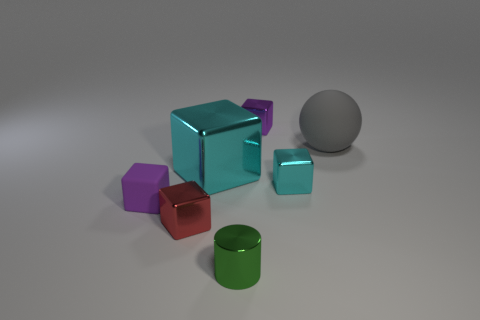What size is the cyan metal thing behind the cyan metallic thing to the right of the small metal cylinder in front of the red object?
Offer a very short reply. Large. What is the color of the thing that is on the left side of the tiny green metal cylinder and behind the tiny purple matte cube?
Provide a short and direct response. Cyan. Is the size of the sphere the same as the cyan object on the left side of the small purple metal object?
Your response must be concise. Yes. Are there any other things that are the same shape as the green object?
Your answer should be compact. No. There is a big metallic thing that is the same shape as the small matte thing; what color is it?
Make the answer very short. Cyan. Does the ball have the same size as the purple matte block?
Make the answer very short. No. What number of other things are there of the same size as the purple metal block?
Ensure brevity in your answer.  4. How many things are large objects to the right of the tiny green cylinder or metallic objects that are on the right side of the tiny red metal object?
Provide a short and direct response. 5. There is another object that is the same size as the gray rubber object; what is its shape?
Your answer should be very brief. Cube. What size is the purple thing that is the same material as the small cyan thing?
Your answer should be compact. Small. 